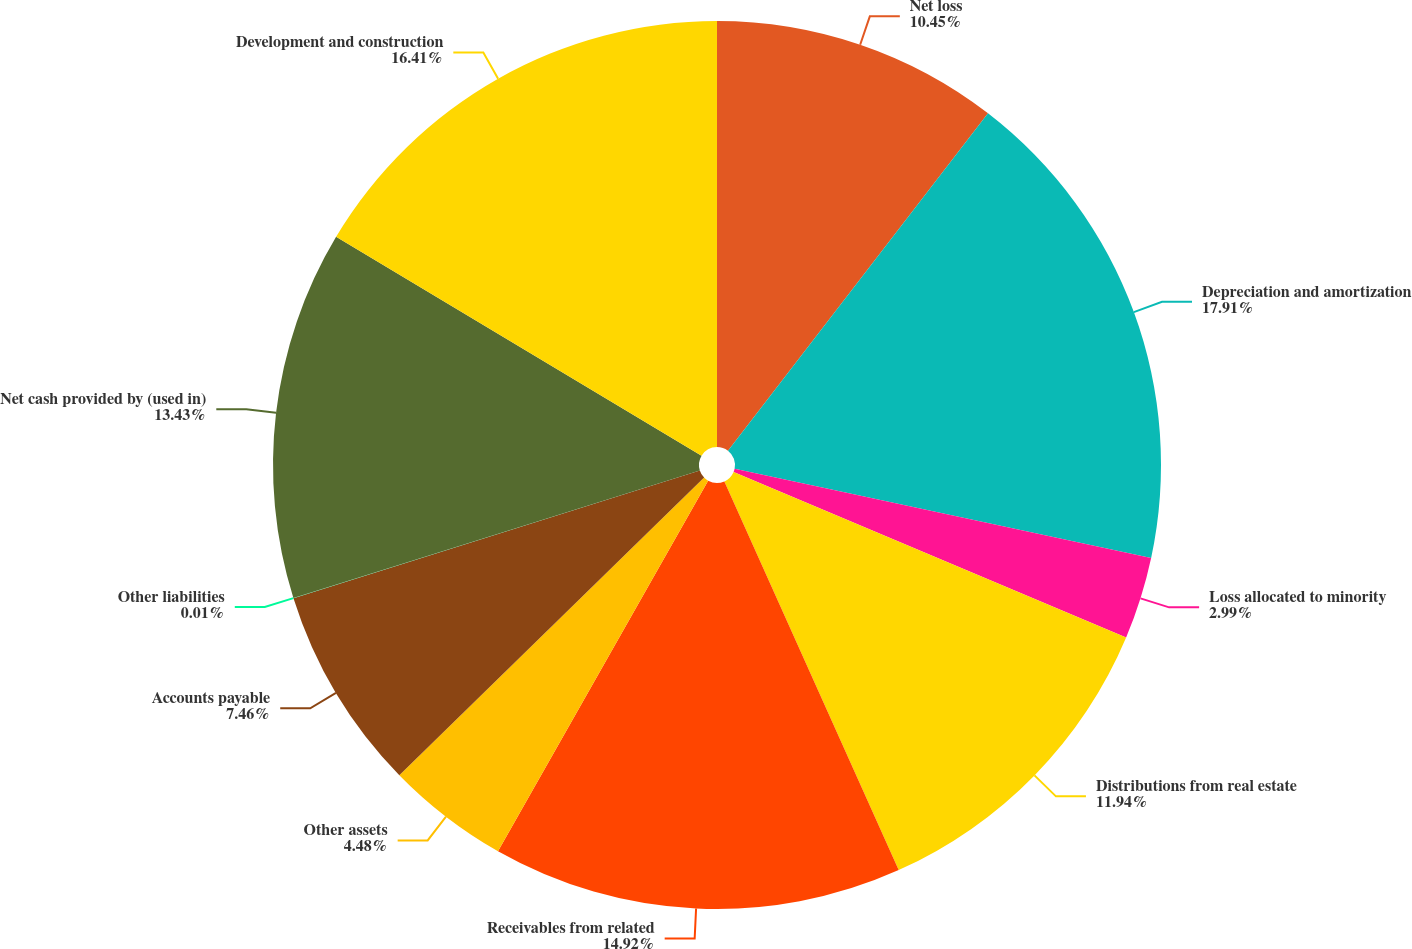Convert chart to OTSL. <chart><loc_0><loc_0><loc_500><loc_500><pie_chart><fcel>Net loss<fcel>Depreciation and amortization<fcel>Loss allocated to minority<fcel>Distributions from real estate<fcel>Receivables from related<fcel>Other assets<fcel>Accounts payable<fcel>Other liabilities<fcel>Net cash provided by (used in)<fcel>Development and construction<nl><fcel>10.45%<fcel>17.91%<fcel>2.99%<fcel>11.94%<fcel>14.92%<fcel>4.48%<fcel>7.46%<fcel>0.01%<fcel>13.43%<fcel>16.41%<nl></chart> 